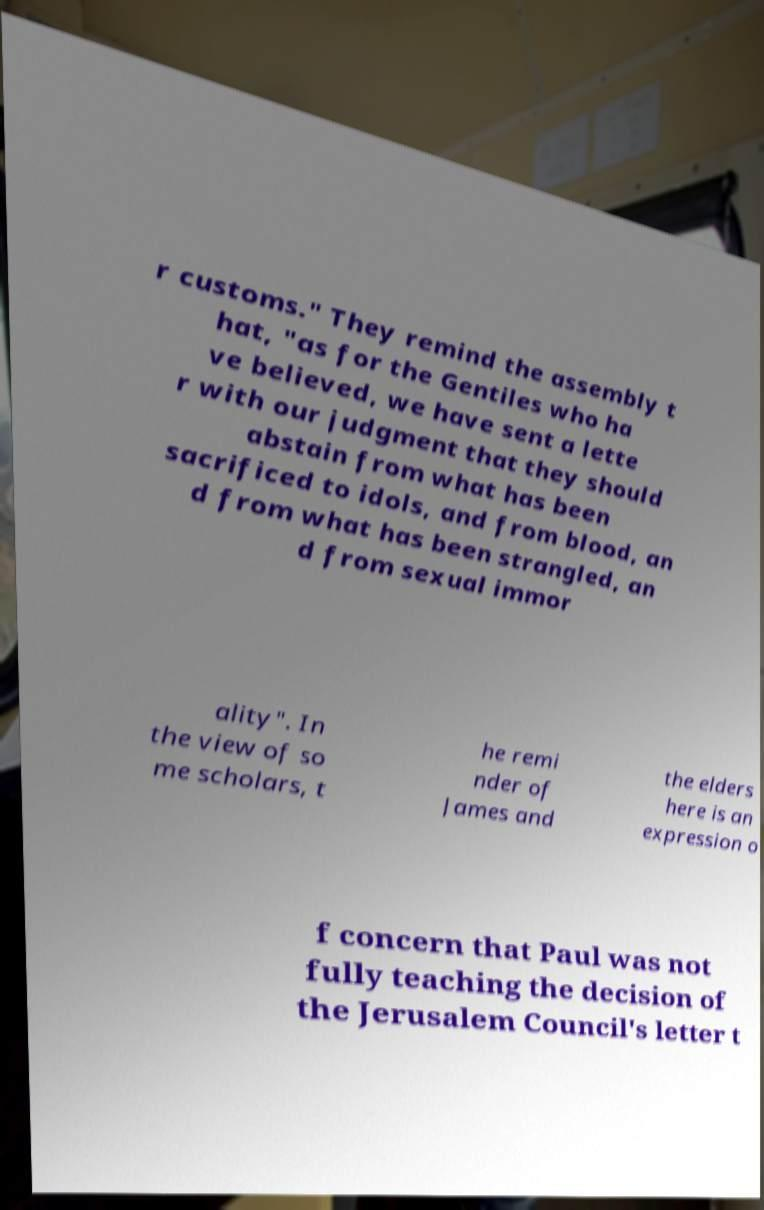Please read and relay the text visible in this image. What does it say? r customs." They remind the assembly t hat, "as for the Gentiles who ha ve believed, we have sent a lette r with our judgment that they should abstain from what has been sacrificed to idols, and from blood, an d from what has been strangled, an d from sexual immor ality". In the view of so me scholars, t he remi nder of James and the elders here is an expression o f concern that Paul was not fully teaching the decision of the Jerusalem Council's letter t 